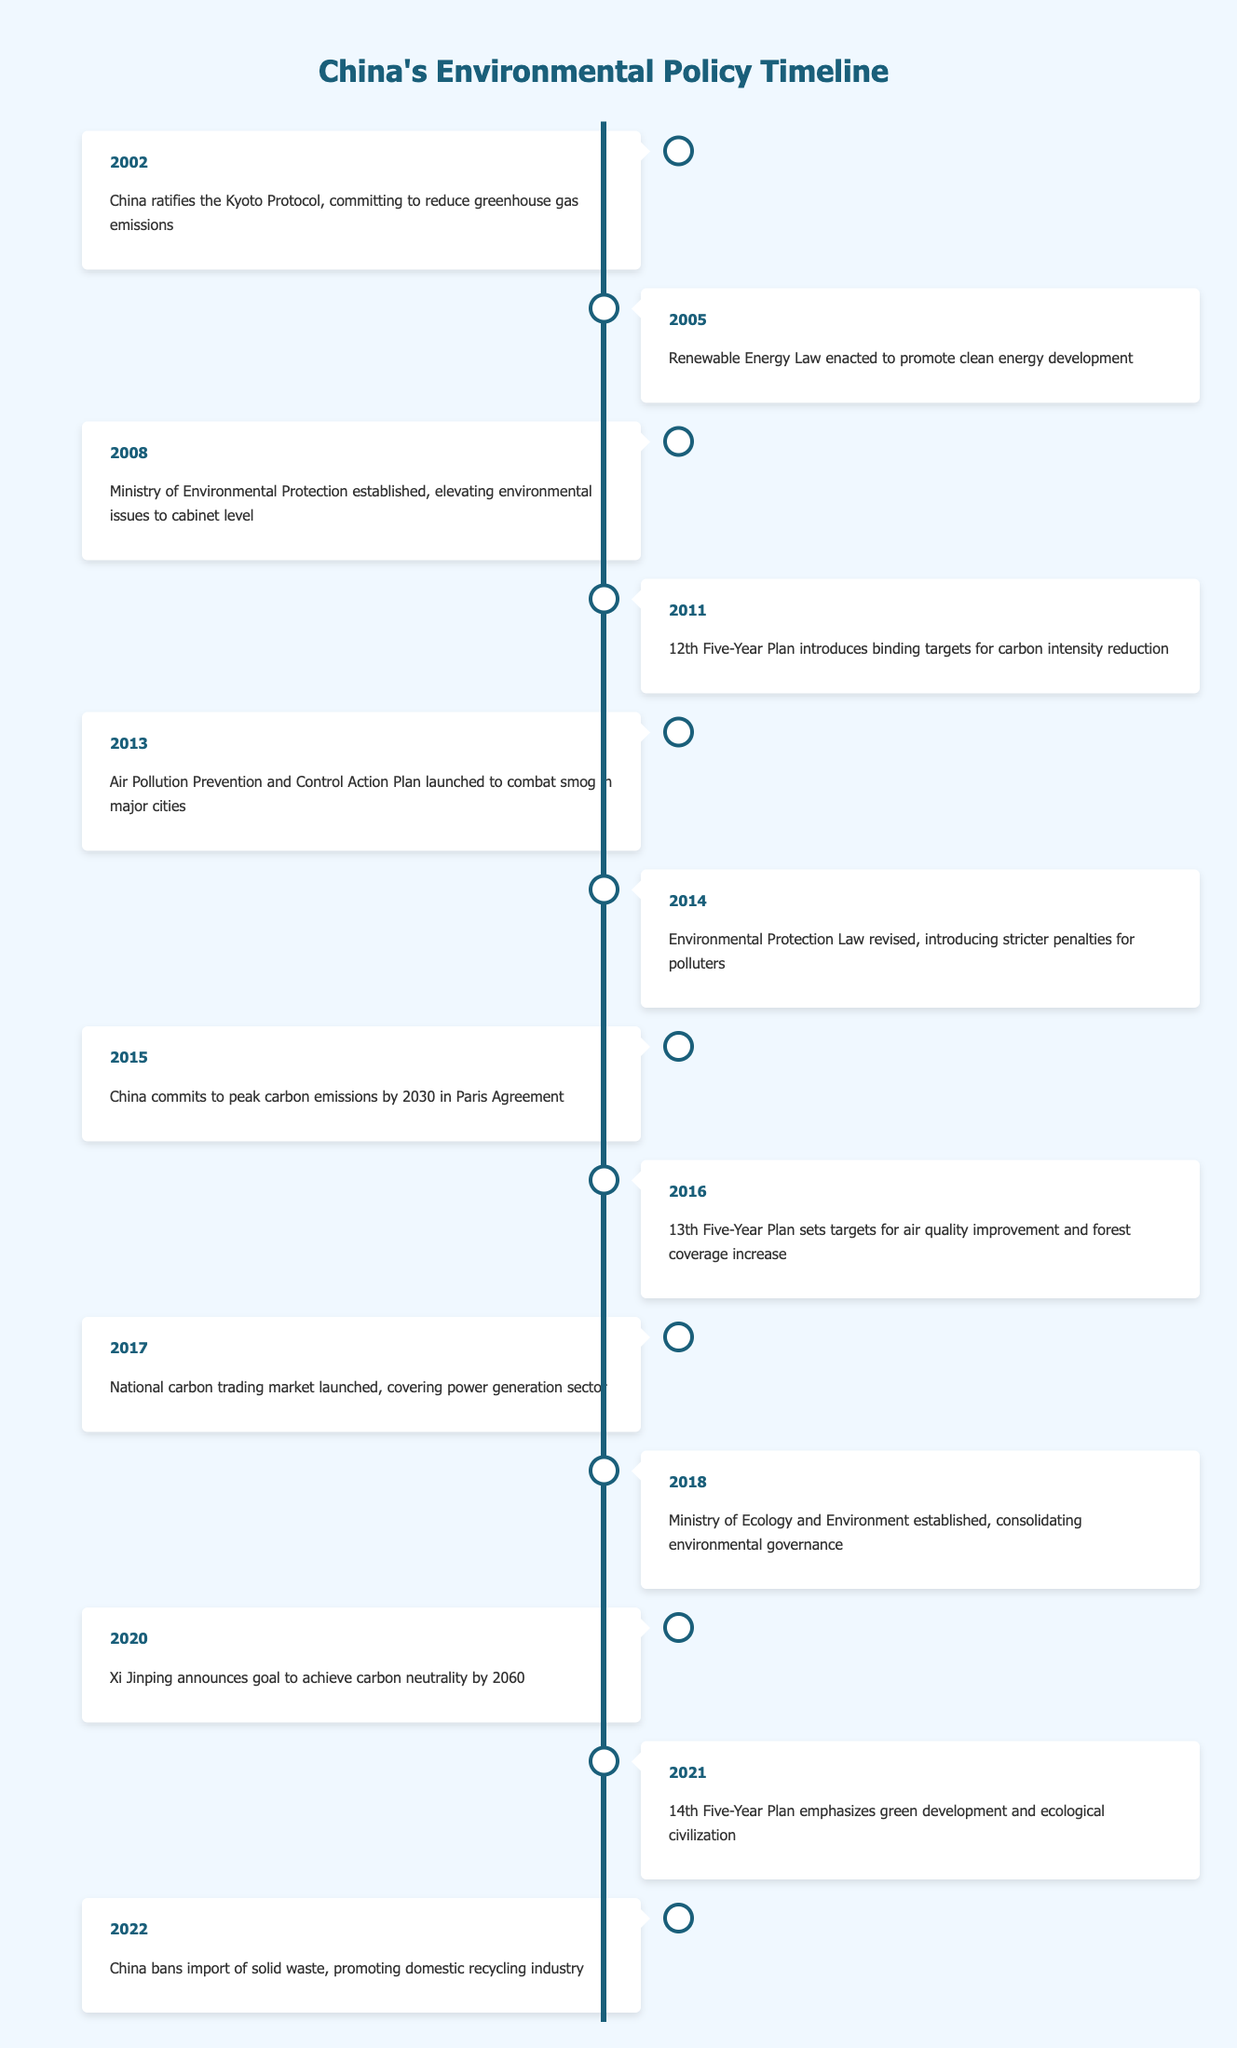What year did China ratify the Kyoto Protocol? The table indicates that China ratified the Kyoto Protocol in 2002, as stated in the first event listed.
Answer: 2002 What major environmental law was enacted in 2005? According to the table, the Renewable Energy Law was enacted in 2005 to promote clean energy development, as indicated in the second event.
Answer: Renewable Energy Law How many significant events related to environmental policies occurred between 2000 and 2010? By counting the relevant entries in the table, we find that there are five significant events from 2002 to 2010 (2002, 2005, 2008, 2011).
Answer: 5 Did China commit to peak carbon emissions in the Paris Agreement? The table confirms that in 2015, China committed to peak carbon emissions by 2030 as part of the Paris Agreement.
Answer: Yes What is the interval between the establishment of the Ministry of Environmental Protection and the launch of the Air Pollution Prevention and Control Action Plan? The Ministry was established in 2008 and the Action Plan launched in 2013. The interval between these two events is 2013 - 2008 = 5 years.
Answer: 5 years What environmental target was set in the 13th Five-Year Plan? The table states that the 13th Five-Year Plan, set in 2016, established targets for both air quality improvement and forest coverage increase, as noted in the seventh event.
Answer: Air quality improvement and forest coverage increase How many years passed from the ratification of the Kyoto Protocol to the announcement of the carbon neutrality goal? The Kyoto Protocol was ratified in 2002 and the carbon neutrality goal was announced in 2020, leading to a difference of 2020 - 2002 = 18 years.
Answer: 18 years Is the Ministry of Ecology and Environment established later than the Environmental Protection Law revision? The Environmental Protection Law was revised in 2014, while the Ministry of Ecology and Environment was established in 2018. Since 2018 comes after 2014, the answer is yes.
Answer: Yes What major recycling initiative did China take in 2022? In 2022, China banned the import of solid waste to promote the domestic recycling industry, which is highlighted as the last event in the timeline.
Answer: Ban on import of solid waste 